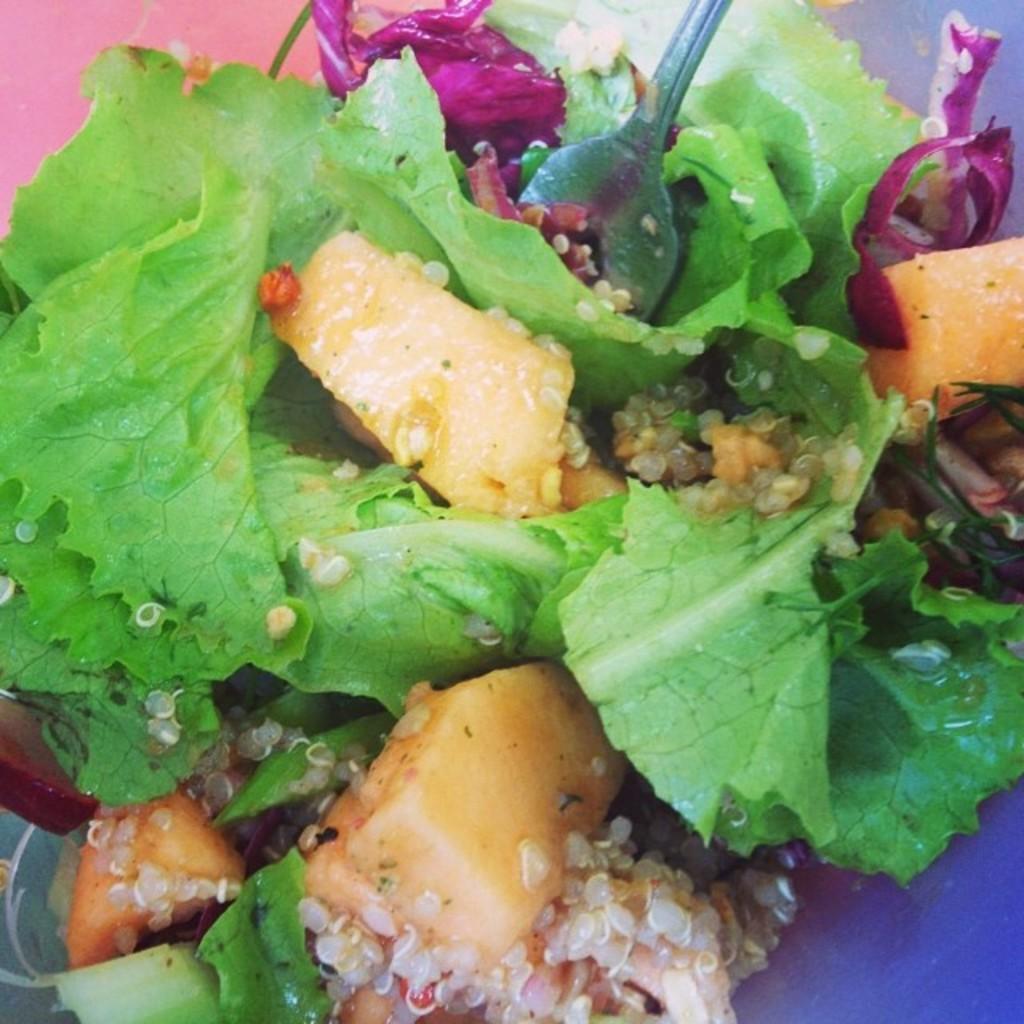Can you describe this image briefly? In this image we can see salad and fork in plate. 